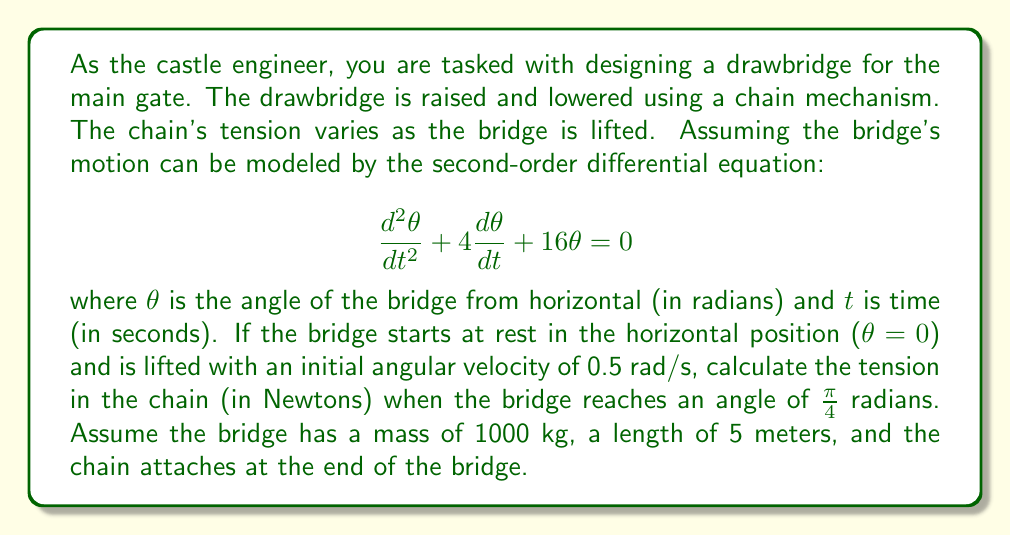Could you help me with this problem? Let's approach this step-by-step:

1) First, we need to solve the differential equation. The general solution for this second-order linear equation is:

   $$\theta(t) = e^{-2t}(A\cos(2\sqrt{3}t) + B\sin(2\sqrt{3}t))$$

2) Using the initial conditions:
   At $t=0$, $\theta(0) = 0$ and $\frac{d\theta}{dt}(0) = 0.5$

   This gives us:
   $$0 = A$$ 
   $$0.5 = -2B + 2\sqrt{3}B$$

3) Solving for B:
   $$B = \frac{0.5}{2(\sqrt{3}-1)} \approx 0.2887$$

4) So our solution is:
   $$\theta(t) = 0.2887e^{-2t}\sin(2\sqrt{3}t)$$

5) To find when $\theta = \frac{\pi}{4}$, we need to solve:
   $$\frac{\pi}{4} = 0.2887e^{-2t}\sin(2\sqrt{3}t)$$

   This can be solved numerically to get $t \approx 0.5861$ seconds.

6) Now we need to find $\frac{d\theta}{dt}$ at this time:
   $$\frac{d\theta}{dt} = 0.2887e^{-2t}(2\sqrt{3}\cos(2\sqrt{3}t) - 2\sin(2\sqrt{3}t))$$

   At $t = 0.5861$, $\frac{d\theta}{dt} \approx 0.2722$ rad/s

7) The tension in the chain can be calculated using the equation:
   $$T = mg(\sin\theta + \frac{L}{g}\frac{d^2\theta}{dt^2})$$

   Where $m$ is the mass, $g$ is gravity (9.8 m/s^2), $L$ is the length, and $\frac{d^2\theta}{dt^2}$ is the angular acceleration.

8) We can find $\frac{d^2\theta}{dt^2}$ from our original differential equation:
   $$\frac{d^2\theta}{dt^2} = -4\frac{d\theta}{dt} - 16\theta$$

   At $t = 0.5861$, $\frac{d^2\theta}{dt^2} \approx -3.5726$ rad/s^2

9) Now we can calculate the tension:
   $$T = 1000 * 9.8 * (\sin(\frac{\pi}{4}) + \frac{5}{9.8} * (-3.5726))$$
   $$T \approx 5303.45 N$$
Answer: The tension in the chain when the drawbridge reaches an angle of $\frac{\pi}{4}$ radians is approximately 5303 N. 